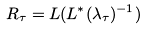<formula> <loc_0><loc_0><loc_500><loc_500>R _ { \tau } = L ( L ^ { * } ( \lambda _ { \tau } ) ^ { - 1 } )</formula> 